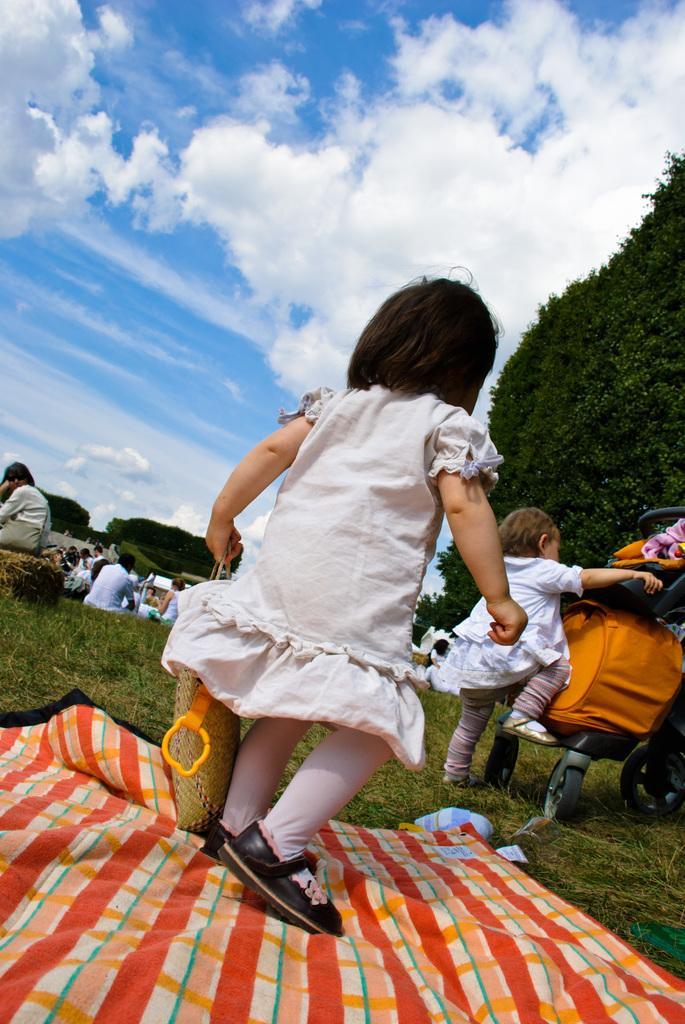Please provide a concise description of this image. In this image I can see the group of people with different color dresses. I can see these people are on the grass. I can see some colorful clothes are on the grass. To the right I can see one person holding the stroller. In the background I can see many trees, clouds and the sky. 